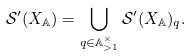Convert formula to latex. <formula><loc_0><loc_0><loc_500><loc_500>\mathcal { S } ^ { \prime } ( X _ { \mathbb { A } } ) = \bigcup _ { q \in \mathbb { A } ^ { \times } _ { > 1 } } \mathcal { S } ^ { \prime } ( X _ { \mathbb { A } } ) _ { q } .</formula> 